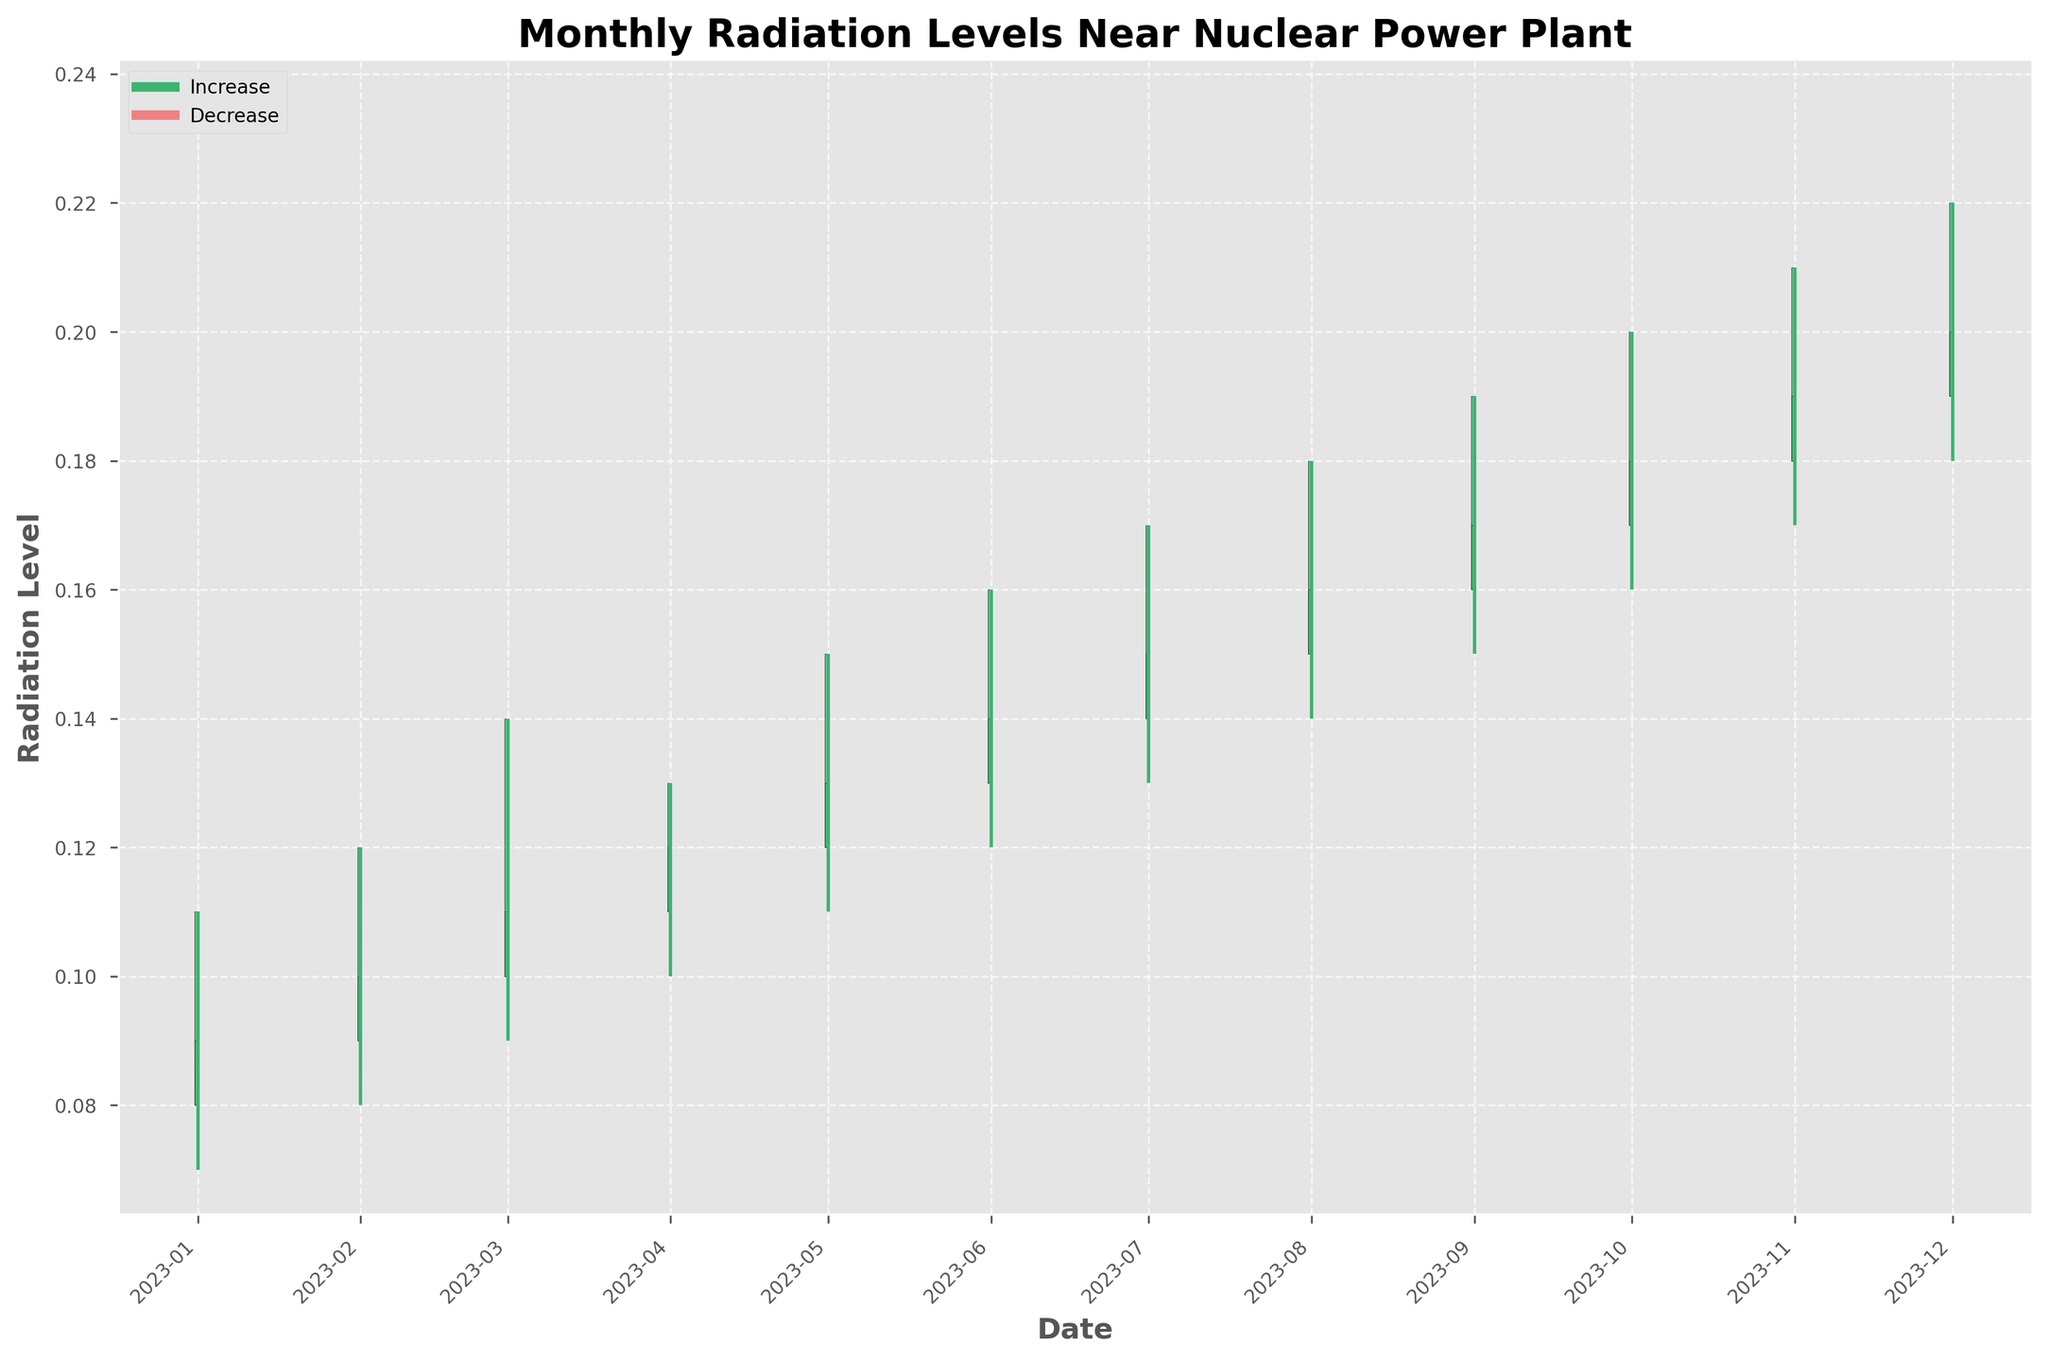What does the title of the chart indicate? The title "Monthly Radiation Levels Near Nuclear Power Plant" suggests that the chart shows the changes in radiation levels over each month around a nuclear power plant, focusing on compliance and potential risks.
Answer: Monthly Radiation Levels Near Nuclear Power Plant What are the colors representing increase and decrease in radiation levels? In the chart, the color green (mediumseagreen) is used to indicate an increase in radiation levels, while the color red (lightcoral) indicates a decrease in radiation levels.
Answer: Green for increase, Red for decrease How many months show a decrease in radiation levels? To determine the number of months with a decrease, we count the bars colored in red. The chart shows no red bars, indicating no months with a decrease in radiation levels.
Answer: 0 months What is the highest recorded radiation level for any month, and which month was it? To find this, look at the highest points on the vertical lines. The highest value is 0.22, recorded in December 2023.
Answer: 0.22 in December 2023 What pattern do you observe in the radiation levels over the 12 months? The radiation levels show a consistent upward trend over the 12 months, with each closing level higher than the previous month's closing level.
Answer: Upward trend What months exhibit the smallest range between high and low radiation levels? Examine the months where the distance between the top and bottom of the vertical lines is shortest. April and May 2023 show the smallest range between high (0.13 and 0.15) and low (0.10 and 0.11) levels, respectively.
Answer: April and May 2023 Which month has the highest variance in radiation levels? The month with the largest difference between high and low values shows the highest variance. March 2023, with a range from 0.09 to 0.14, exhibits the largest variance.
Answer: March 2023 How do the radiation levels in October 2023 compare to those in April 2023? Compare the high, low, and closing values. October’s high (0.20), low (0.16), and close (0.18) are higher than April’s high (0.13), low (0.10), and close (0.12).
Answer: Higher in October 2023 Are there any months where the opening radiation level was equal to the closing level? Since the color of the bar indicates change, no bars in the figure are neutral (unchanged). Therefore, there are no months where the opening and closing levels are equal.
Answer: No Does the data suggest the plant is maintaining safe radiation levels over the year? Given the upward trend, it’s essential to compare the data against safety thresholds. Without specific safety thresholds in the chart, we can’t conclusively determine safety compliance solely from the given figure. Further specific limits are necessary.
Answer: Uncertain without safety thresholds 